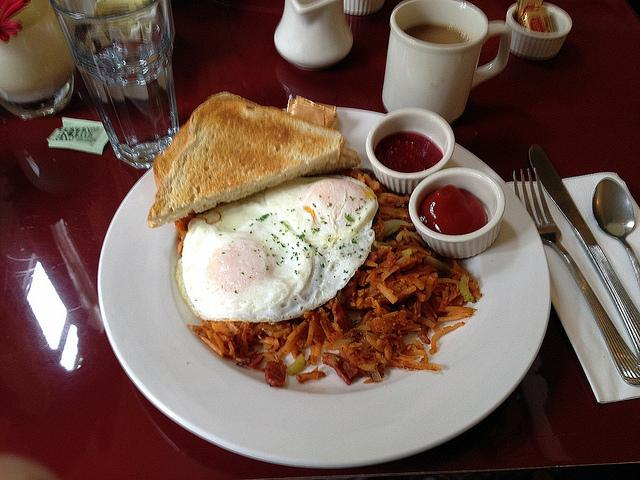What time of day is most likely?

Choices:
A) night
B) evening
C) afternoon
D) morning morning 